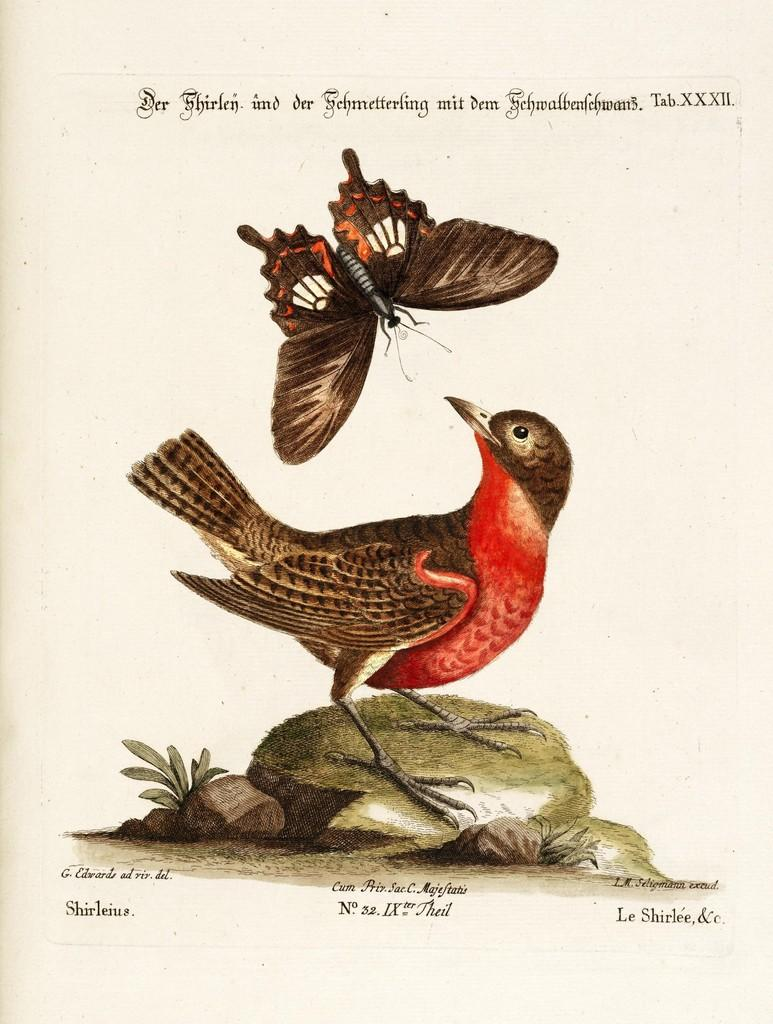What is the main subject of the poster in the image? The poster depicts a rock. Are there any living creatures on the rock? Yes, there is a bird and a butterfly on the rock. What can be seen on the poster besides the rock and the creatures? There is writing on the poster. How many legs does the rock have in the image? Rocks do not have legs, as they are inanimate objects. 